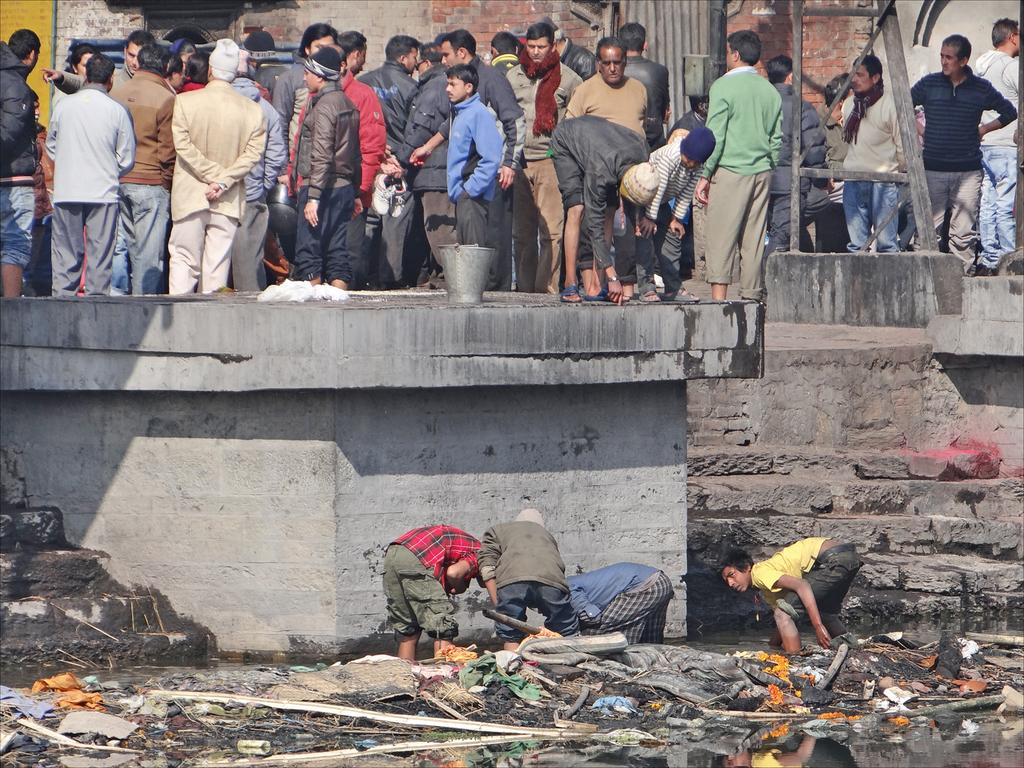What are the four people in the image doing? The four people are standing in the garbage. What can be seen in the distance in the image? There is a crowd visible at the top of the image. What is in the background of the image? There is a wall in the background of the image. Where is the stove located in the image? There is no stove present in the image. What type of calculator is being used by the people in the garbage? There is no calculator present in the image; the four people are standing in the garbage. 